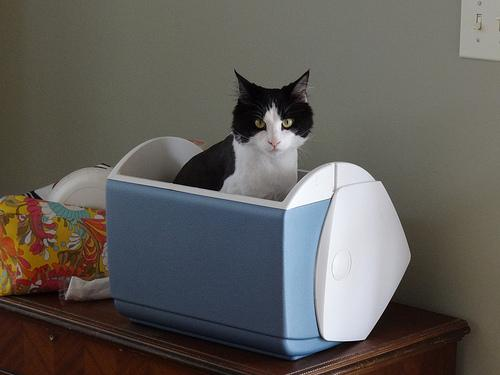What is sticking out of the floral bag? Items are sticking out of the floral bag. What kind of eyes and nose does the cat have? The cat has green eyes and a pink nose. Analyze the sentiment or mood of the image. The image has a playful and positive mood, showing a curious cat exploring and enjoying a cozy space. What is the cooler sitting on, and what is its color? The cooler is sitting on a brown wooden stand. What kind of interaction is shown between the cat and the cooler? The cat is sitting inside the cooler, indicating curiosity and playfulness. Describe the position and description of the light switch in the image. There is a white light switch on the wall to the right of the cat. Can you count how many ears are visible on the cat and describe their color? Two ears are visible, and they have black fur. Tell me the main object and its main color in the image. The main object in the image is a black and white cat sitting in a blue and white cooler. Name one other object in the image besides the cat, the cooler, and the stand. A brightly colored bag with a multicolored patterned fabric. Describe the wall to the left of the cat's head. The wall to the left of the cat's head is painted in a light green color. 